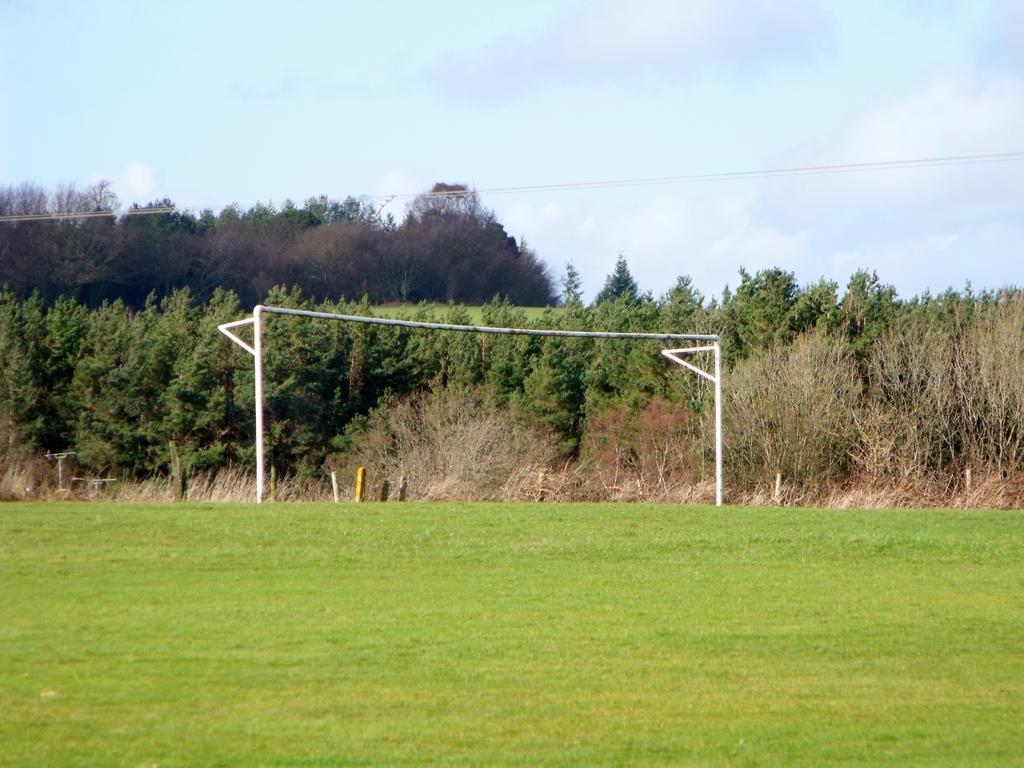What type of vegetation can be seen in the image? There are trees in the image. What sports-related object is visible in the image? There is a goal pole in the image. What type of ground surface is present in the image? Grass is present on the ground in the image. How would you describe the sky in the image? The sky is blue and cloudy in the image. How many bricks are stacked on top of the goal pole in the image? There are no bricks present in the image, and the goal pole is not stacked with bricks. Can you see any bees flying around the trees in the image? There is no mention of bees in the image, so we cannot determine if any are present. 